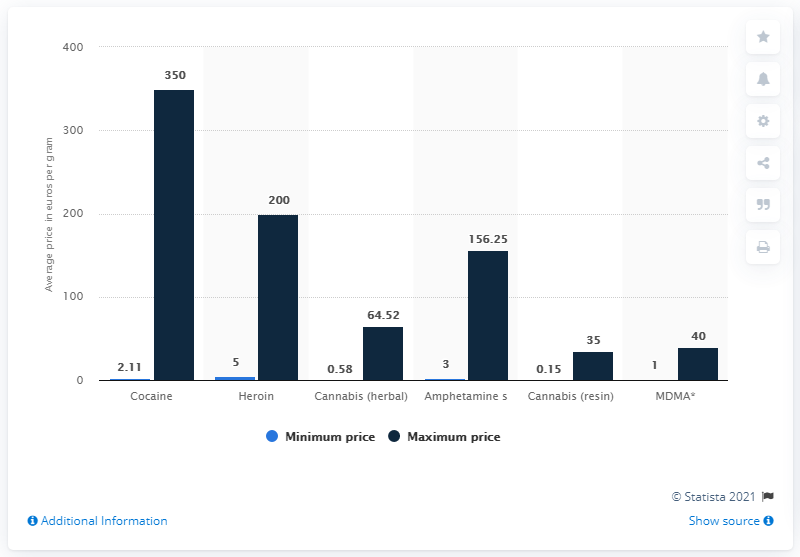Highlight a few significant elements in this photo. In 2017, cocaine was the illicit drug with the highest average price per gram in Sweden. 